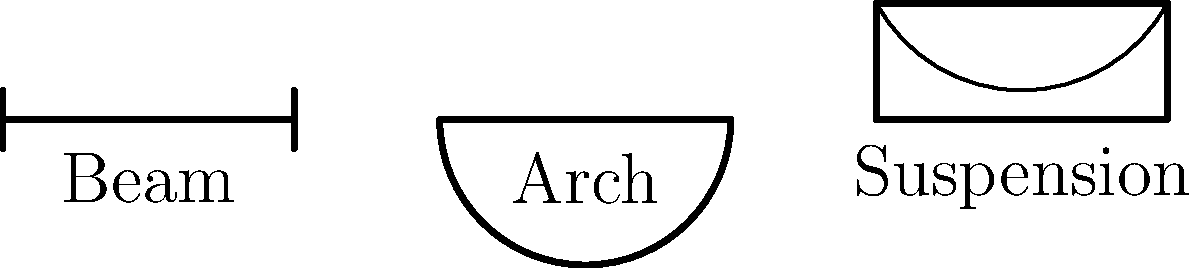In your poetic journey through the world of engineering, you encounter three types of bridges spanning rivers of creativity. Each bridge type - beam, arch, and suspension - has its unique way of carrying loads. Which of these bridge types would you choose to metaphorically represent resilience and strength in the face of adversity, and why? To answer this question, let's explore the characteristics of each bridge type:

1. Beam bridge:
   - Simplest type of bridge
   - Supports the load directly on beams or girders
   - Transfers the weight straight down to the supports
   - Represents straightforward strength but limited in span

2. Arch bridge:
   - Uses the natural strength of an arch to spread the load
   - Can span longer distances than beam bridges
   - The curved structure distributes the weight evenly
   - Symbolizes the power of embracing pressure and using it as strength

3. Suspension bridge:
   - Can span the longest distances of all bridge types
   - Uses cables to transfer the load to towers and anchorages
   - The deck is suspended from these main cables
   - Represents flexibility and the ability to bear great weights while appearing light

Considering the theme of resilience and strength in the face of adversity, the arch bridge would be the most fitting metaphor. Here's why:

1. The arch shape naturally resists compression forces, much like how resilience helps us withstand pressure.
2. The structure of an arch bridge becomes stronger as more weight is applied, similar to how adversity can make us stronger.
3. Arch bridges have been used for thousands of years, symbolizing enduring strength over time.
4. The curved form of the arch can represent the ability to bend without breaking, a key aspect of resilience.

While all bridge types demonstrate strength, the arch bridge's unique property of becoming stronger under pressure makes it the most powerful metaphor for resilience in the face of adversity.
Answer: Arch bridge 